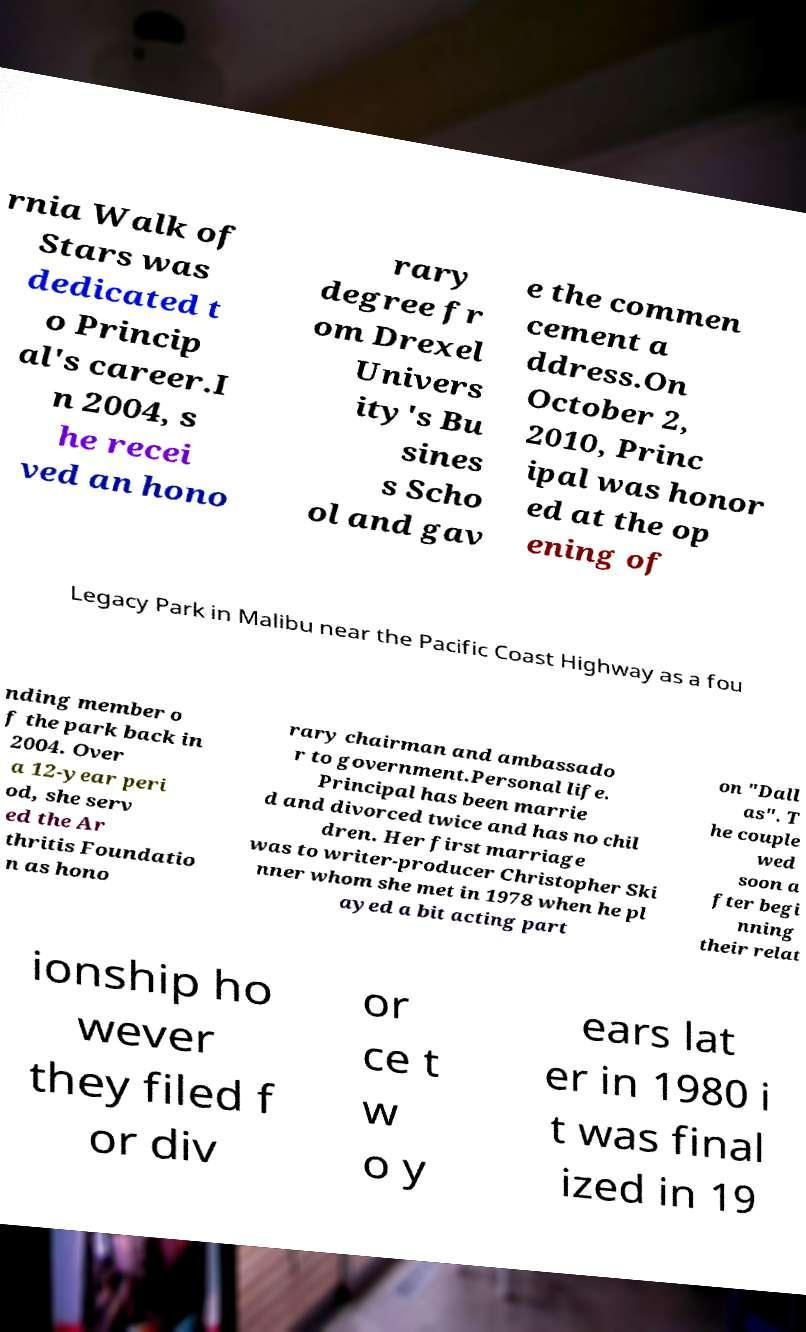Please identify and transcribe the text found in this image. rnia Walk of Stars was dedicated t o Princip al's career.I n 2004, s he recei ved an hono rary degree fr om Drexel Univers ity's Bu sines s Scho ol and gav e the commen cement a ddress.On October 2, 2010, Princ ipal was honor ed at the op ening of Legacy Park in Malibu near the Pacific Coast Highway as a fou nding member o f the park back in 2004. Over a 12-year peri od, she serv ed the Ar thritis Foundatio n as hono rary chairman and ambassado r to government.Personal life. Principal has been marrie d and divorced twice and has no chil dren. Her first marriage was to writer-producer Christopher Ski nner whom she met in 1978 when he pl ayed a bit acting part on "Dall as". T he couple wed soon a fter begi nning their relat ionship ho wever they filed f or div or ce t w o y ears lat er in 1980 i t was final ized in 19 